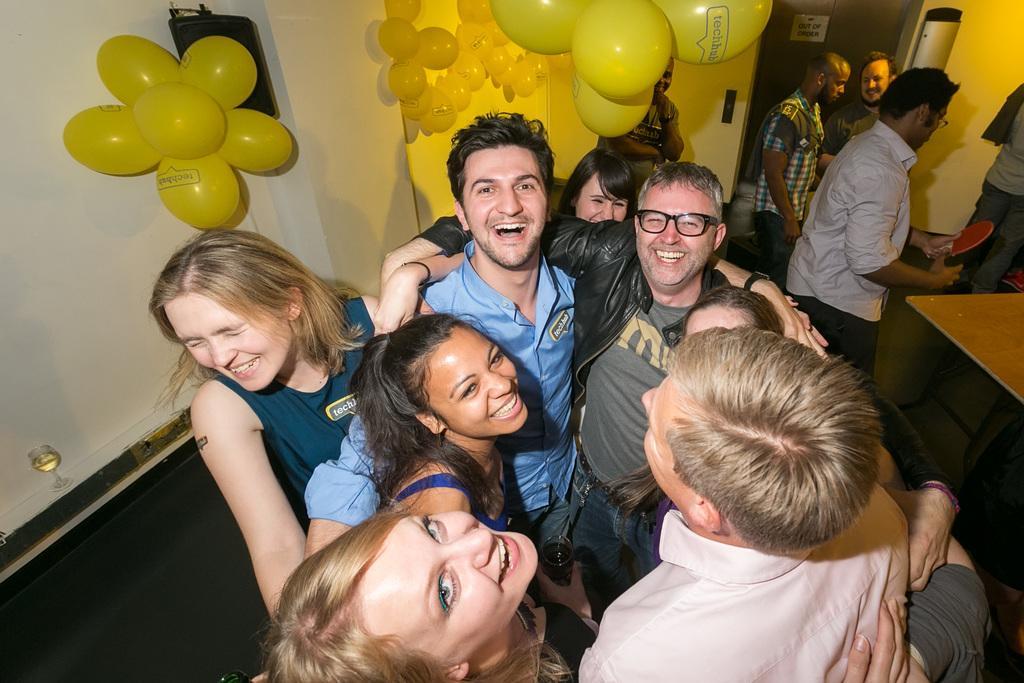In one or two sentences, can you explain what this image depicts? In the foreground, I can see a group of people on the floor and a table. In the background, I can see balloons on a wall and a door. This image taken, maybe in a hall. 